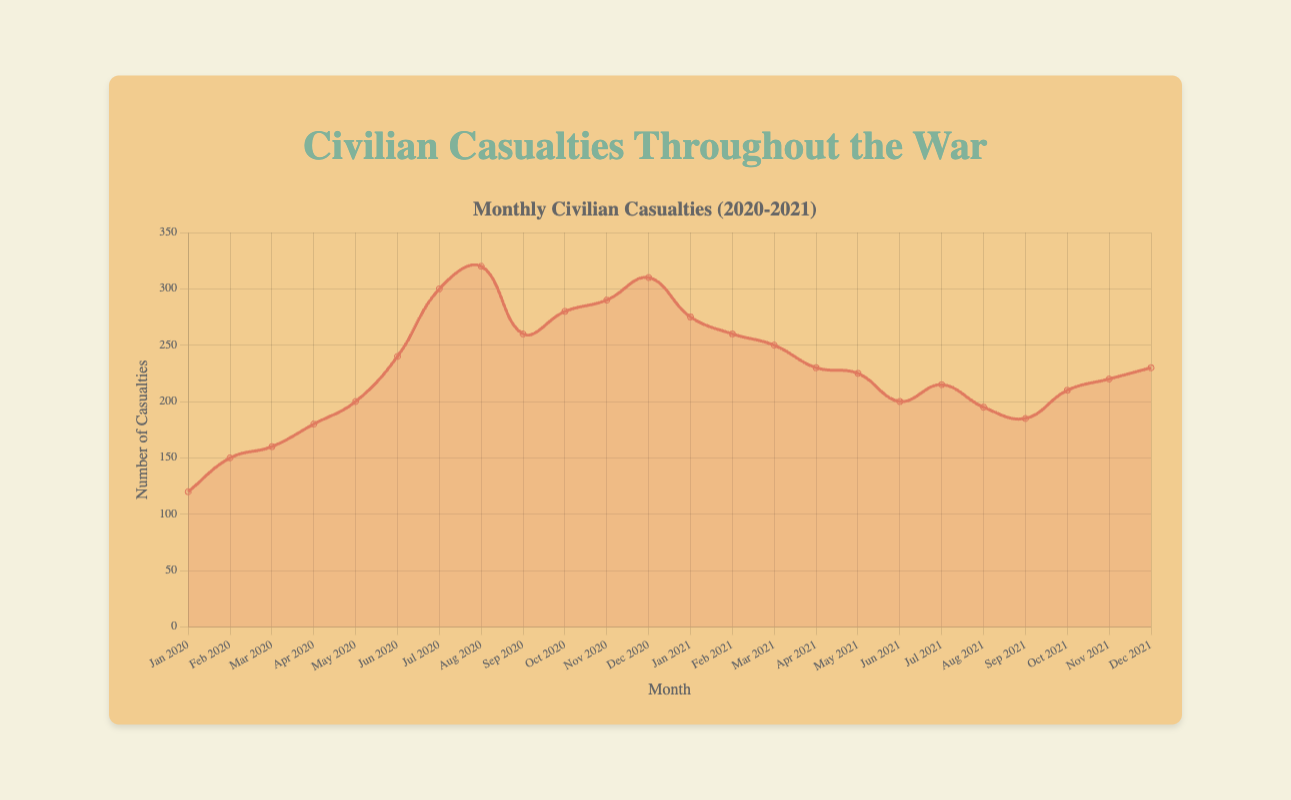What was the highest number of civilian casualties recorded in a month during 2020? The plot shows the number of civilian casualties for each month. The highest point in the 2020 data is in August with 320 casualties.
Answer: 320 In which month of 2021 were the civilian casualties the lowest? The lowest point in the 2021 data is in September with 185 casualties.
Answer: September How does the number of casualties in July 2020 compare to July 2021? In the plot, July 2020 has 300 casualties and July 2021 has 215 casualties. Comparing these, July 2020 has more casualties.
Answer: July 2020 has more What is the average number of casualties per month in 2020? The total number of casualties in 2020 is 2910. Dividing this by 12 months, the average is 2910/12 = 242.5.
Answer: 242.5 During which months did the Northern Province see the highest and lowest casualties? The plot shows Northern Province data with the highest in October 2020 (280) and the lowest in January 2020 (120).
Answer: Highest: October 2020, Lowest: January 2020 How many months in 2020 had civilian casualties greater than 200? Examining the plot for 2020 shows 6 months with casualties greater than 200: June, July, August, September, October, November, and December.
Answer: 6 What is the total number of civilian casualties in the first quarter (Jan, Feb, Mar) of 2021? The casualties for Jan (275), Feb (260), Mar (250) 2021 sums to 275 + 260 + 250 = 785.
Answer: 785 Compare the general trend of casualties between 2020 and 2021. Did the casualties generally increase or decrease in 2021 compared to 2020? The plot shows a higher trend in casualties in 2020 with peaks in summer months, whereas 2021 shows a general decline.
Answer: Decrease Which region saw a decrease in civilian casualties from March 2020 to March 2021? Comparing March 2020 (Eastern Province, 160) and March 2021 (Western Province, 250) on the plot, the Eastern Province had a decrease between these points.
Answer: Eastern Province What is the sum of casualties for the months of June in both years? June 2020 had 240 casualties while June 2021 had 200. Adding these gives 240 + 200 = 440.
Answer: 440 